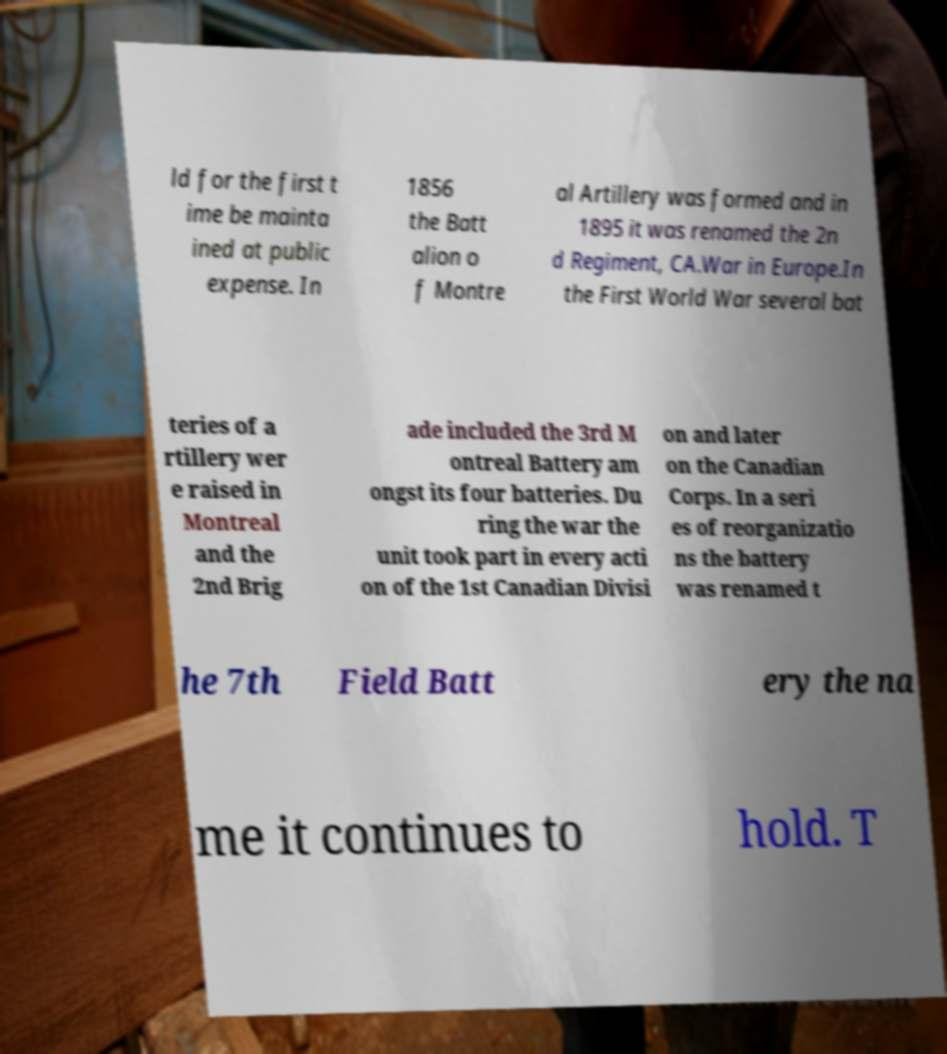Can you accurately transcribe the text from the provided image for me? ld for the first t ime be mainta ined at public expense. In 1856 the Batt alion o f Montre al Artillery was formed and in 1895 it was renamed the 2n d Regiment, CA.War in Europe.In the First World War several bat teries of a rtillery wer e raised in Montreal and the 2nd Brig ade included the 3rd M ontreal Battery am ongst its four batteries. Du ring the war the unit took part in every acti on of the 1st Canadian Divisi on and later on the Canadian Corps. In a seri es of reorganizatio ns the battery was renamed t he 7th Field Batt ery the na me it continues to hold. T 